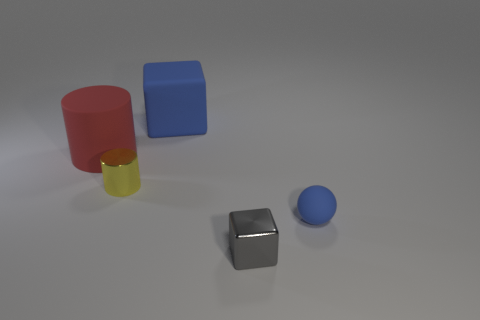Subtract all yellow cylinders. Subtract all yellow spheres. How many cylinders are left? 1 Add 5 small green things. How many objects exist? 10 Subtract all balls. How many objects are left? 4 Subtract 0 green cylinders. How many objects are left? 5 Subtract all large brown cylinders. Subtract all small metallic objects. How many objects are left? 3 Add 3 big matte cylinders. How many big matte cylinders are left? 4 Add 2 gray rubber balls. How many gray rubber balls exist? 2 